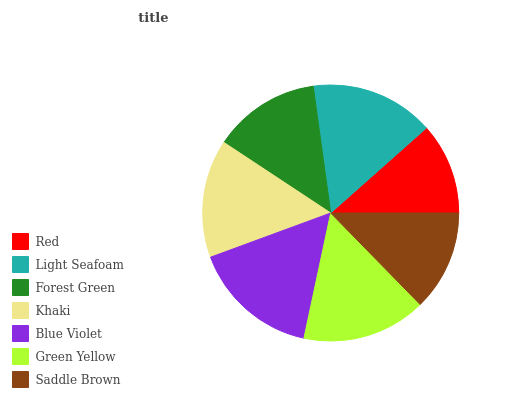Is Red the minimum?
Answer yes or no. Yes. Is Blue Violet the maximum?
Answer yes or no. Yes. Is Light Seafoam the minimum?
Answer yes or no. No. Is Light Seafoam the maximum?
Answer yes or no. No. Is Light Seafoam greater than Red?
Answer yes or no. Yes. Is Red less than Light Seafoam?
Answer yes or no. Yes. Is Red greater than Light Seafoam?
Answer yes or no. No. Is Light Seafoam less than Red?
Answer yes or no. No. Is Khaki the high median?
Answer yes or no. Yes. Is Khaki the low median?
Answer yes or no. Yes. Is Green Yellow the high median?
Answer yes or no. No. Is Blue Violet the low median?
Answer yes or no. No. 